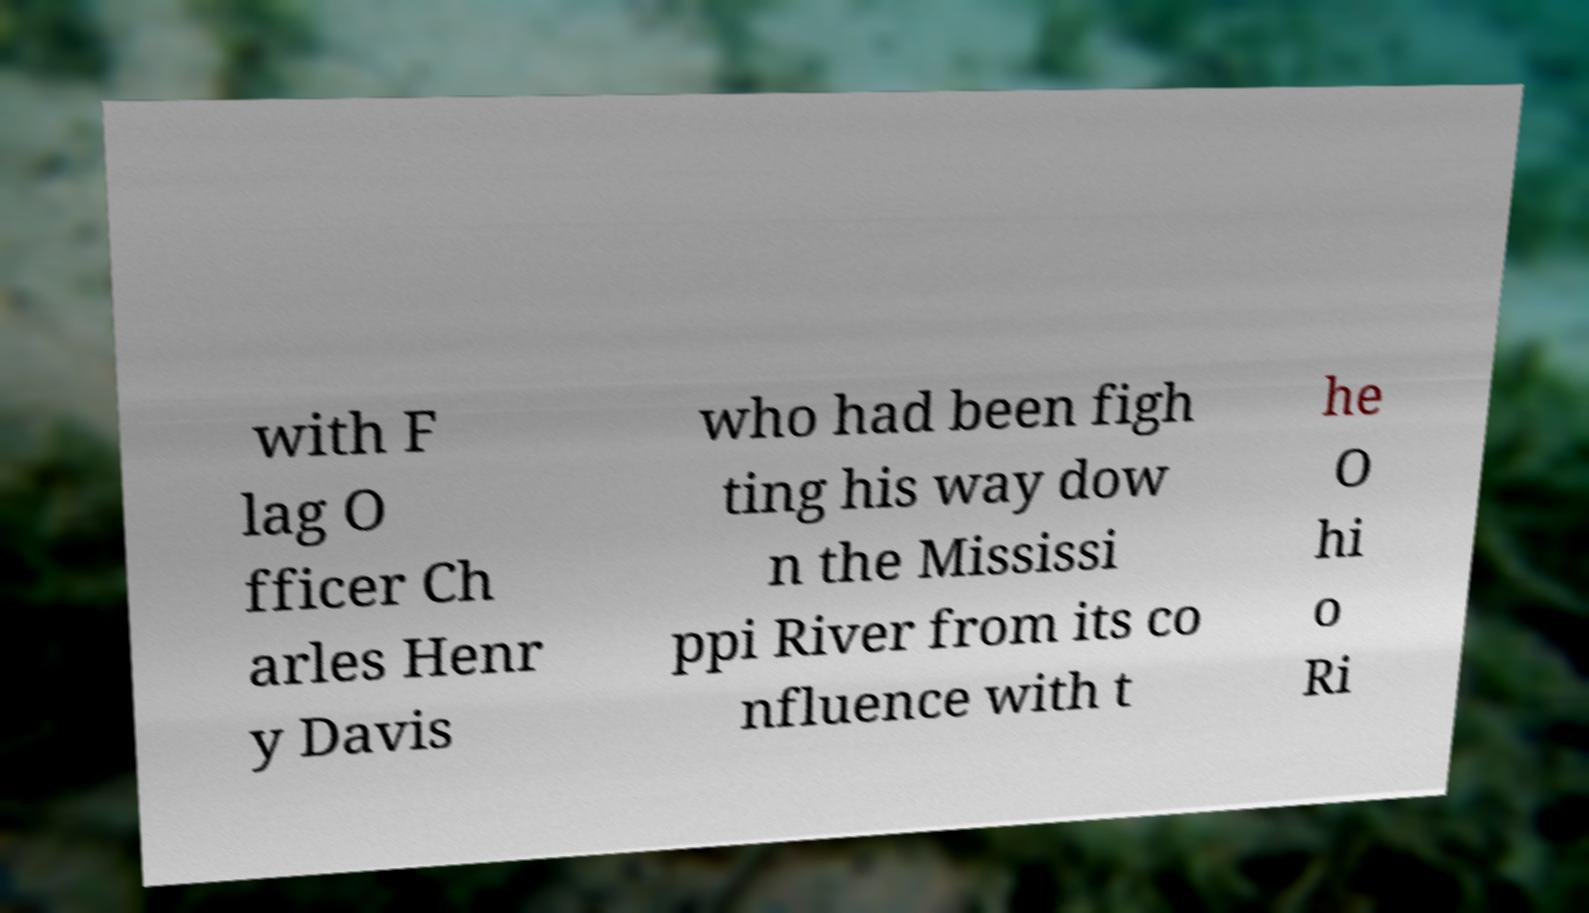For documentation purposes, I need the text within this image transcribed. Could you provide that? with F lag O fficer Ch arles Henr y Davis who had been figh ting his way dow n the Mississi ppi River from its co nfluence with t he O hi o Ri 